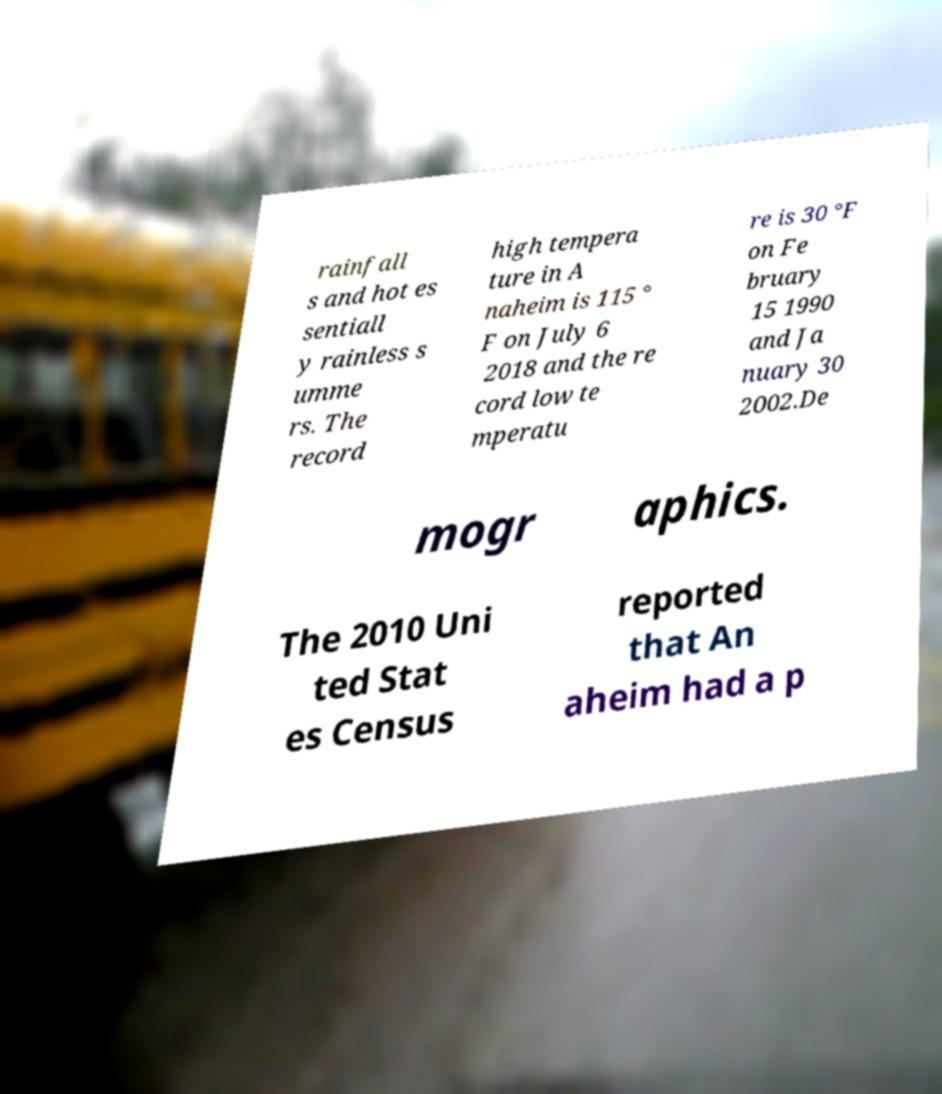Can you accurately transcribe the text from the provided image for me? rainfall s and hot es sentiall y rainless s umme rs. The record high tempera ture in A naheim is 115 ° F on July 6 2018 and the re cord low te mperatu re is 30 °F on Fe bruary 15 1990 and Ja nuary 30 2002.De mogr aphics. The 2010 Uni ted Stat es Census reported that An aheim had a p 